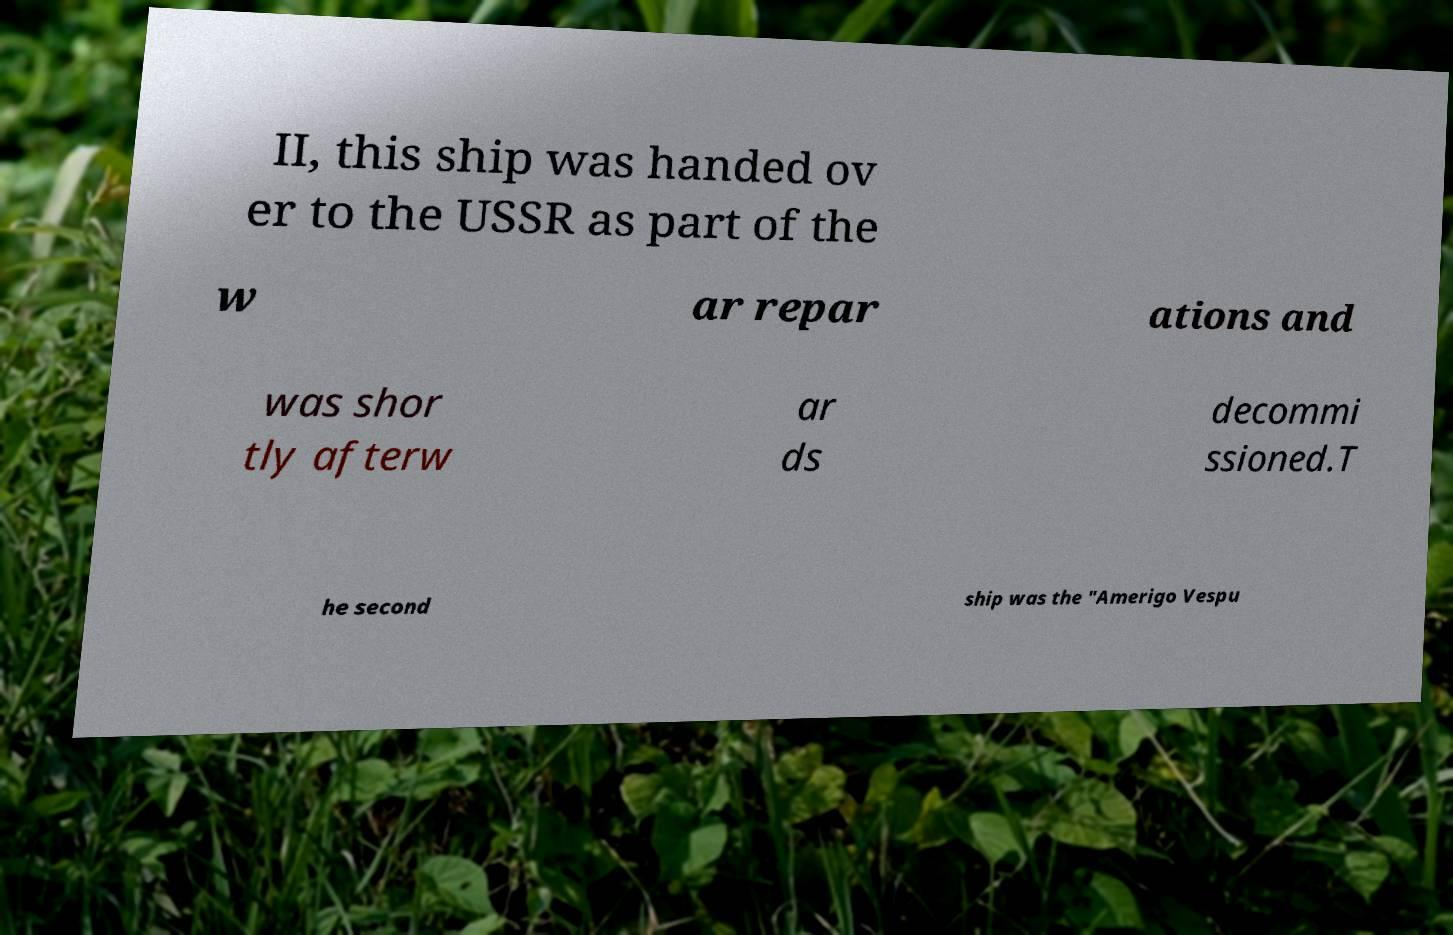There's text embedded in this image that I need extracted. Can you transcribe it verbatim? II, this ship was handed ov er to the USSR as part of the w ar repar ations and was shor tly afterw ar ds decommi ssioned.T he second ship was the "Amerigo Vespu 